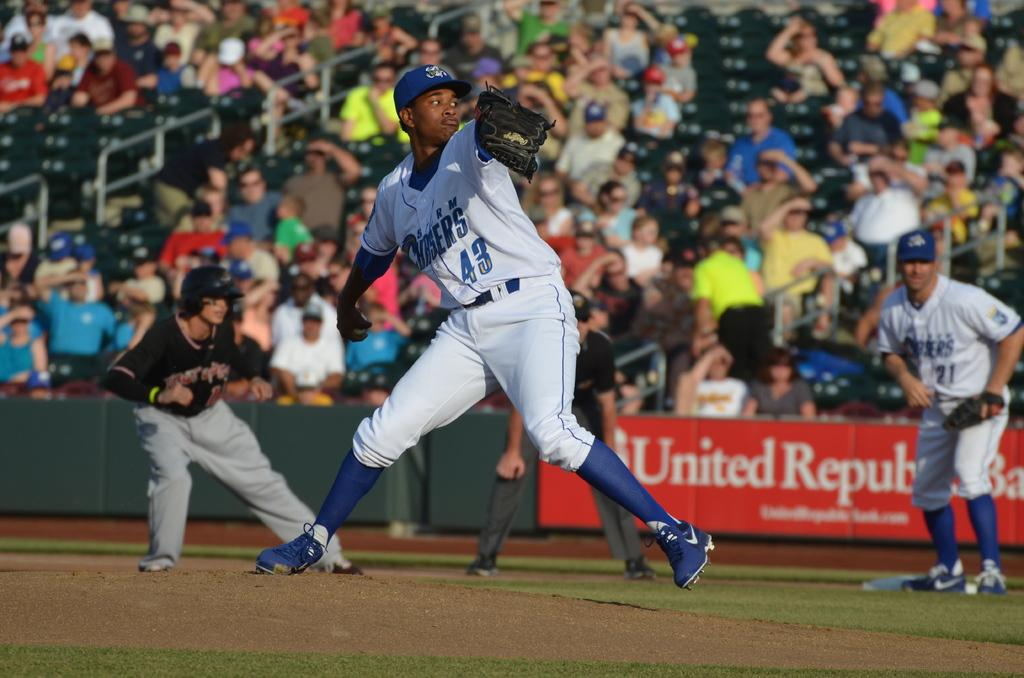<image>
Give a short and clear explanation of the subsequent image. A baseball game is being played in front of a large crowd who sit behind an advertsing board for United Republic Bank 